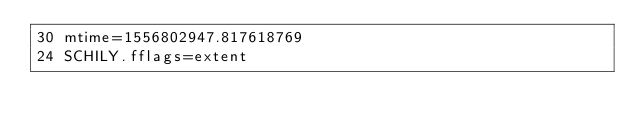<code> <loc_0><loc_0><loc_500><loc_500><_PHP_>30 mtime=1556802947.817618769
24 SCHILY.fflags=extent
</code> 